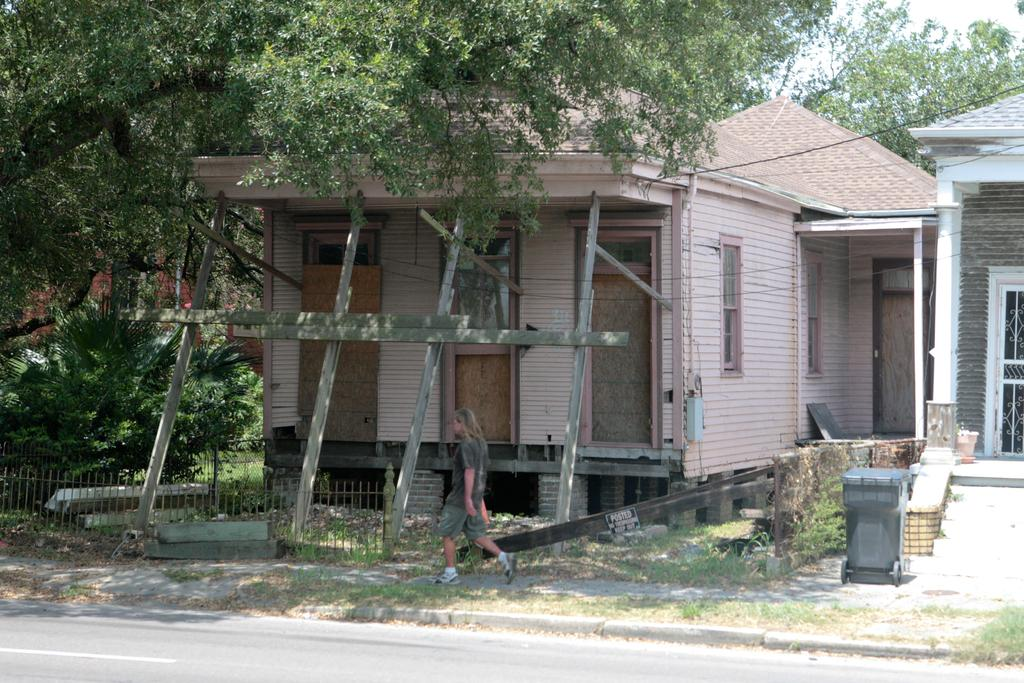What is the person in the image doing? There is a person walking on the pavement. What can be seen beside the pavement? There are houses and trees beside the pavement. Can you describe the trash can in the image? There is a trash can in front of a house. Where can the person sit down and rest in the image? There is no chair or designated resting area visible in the image. 